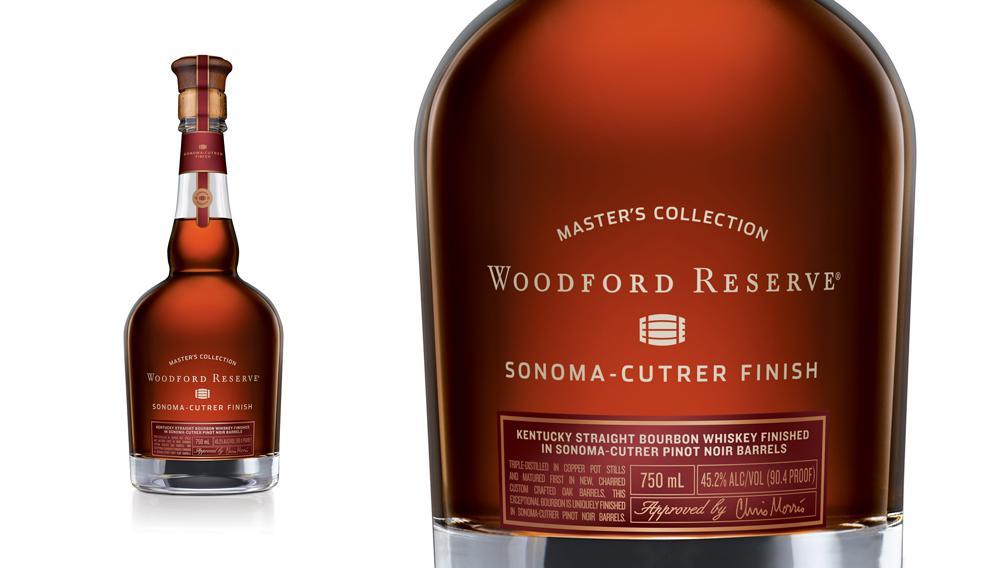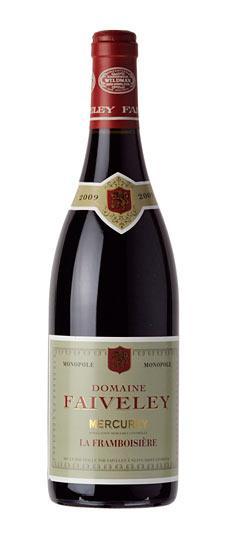The first image is the image on the left, the second image is the image on the right. For the images displayed, is the sentence "There are fewer than 4 bottles across both images." factually correct? Answer yes or no. Yes. The first image is the image on the left, the second image is the image on the right. Analyze the images presented: Is the assertion "One image contains a horizontal row of three wine bottles." valid? Answer yes or no. No. 